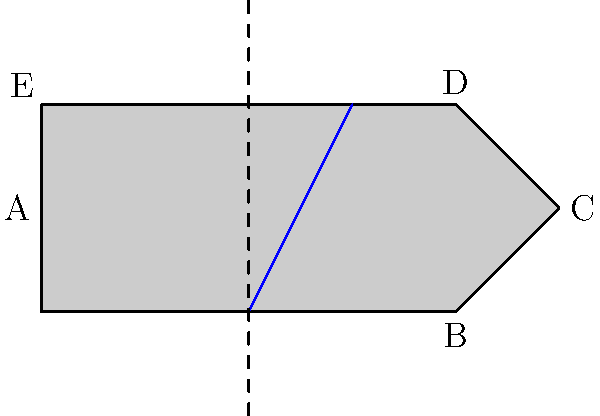Consider the simplified design of a vintage fountain pen nib shown above. What is the order of the symmetry group of this nib design, assuming the slit (blue line) is an essential part of the design? To determine the order of the symmetry group, we need to identify all symmetry operations that leave the nib design unchanged:

1. Identity transformation (always present): 1 operation

2. Reflection: 
   The dashed line represents a line of symmetry. Reflecting the nib across this line leaves the design unchanged. This adds 1 more operation.

3. Rotations: 
   There are no rotations (other than 360°, which is the identity) that preserve the design due to the asymmetry created by the slit.

4. No other symmetries exist for this design.

Therefore, the symmetry group consists of two elements: the identity and the reflection.

In group theory, this symmetry group is isomorphic to the cyclic group of order 2, often denoted as $C_2$ or $\mathbb{Z}_2$.

The order of a group is the number of elements in the group. In this case, there are 2 elements in the symmetry group.
Answer: 2 